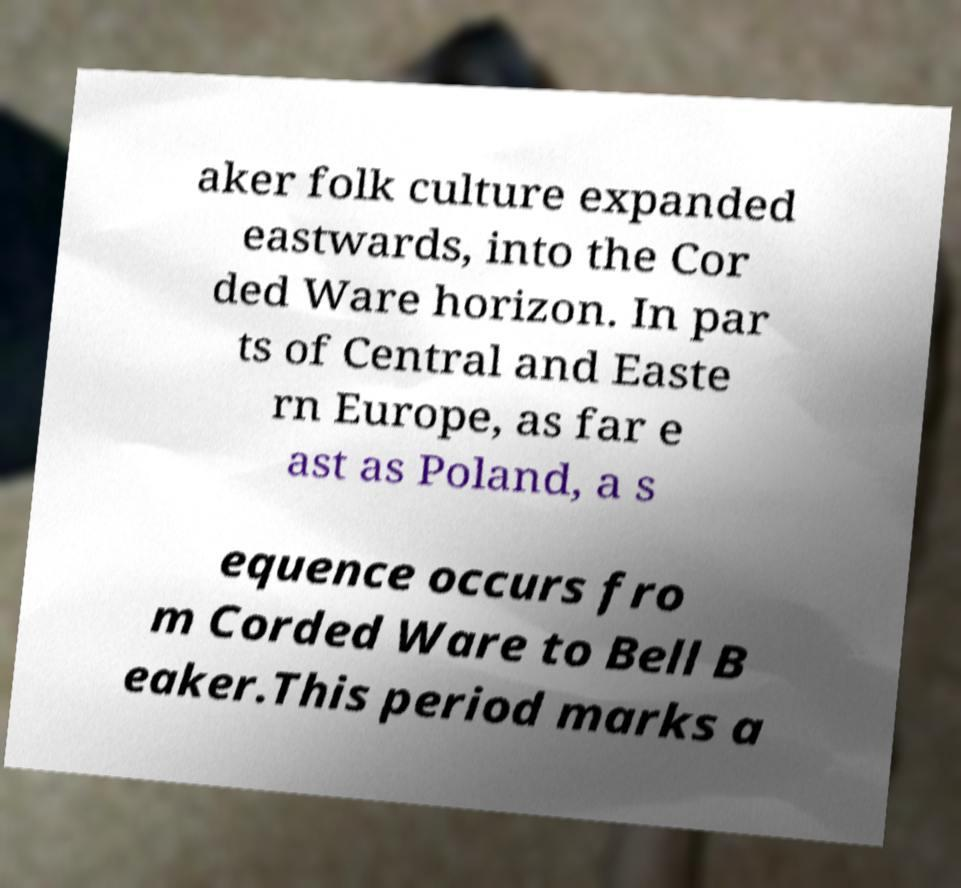I need the written content from this picture converted into text. Can you do that? aker folk culture expanded eastwards, into the Cor ded Ware horizon. In par ts of Central and Easte rn Europe, as far e ast as Poland, a s equence occurs fro m Corded Ware to Bell B eaker.This period marks a 